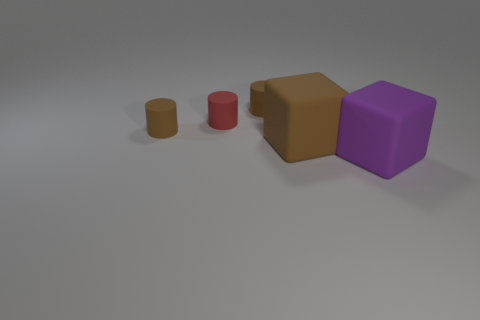Subtract all brown cylinders. How many cylinders are left? 1 Add 2 large yellow metallic objects. How many objects exist? 7 Subtract all brown cylinders. How many cylinders are left? 1 Subtract 2 cubes. How many cubes are left? 0 Subtract all purple spheres. Subtract all small red matte objects. How many objects are left? 4 Add 3 brown matte cylinders. How many brown matte cylinders are left? 5 Add 5 big purple matte cylinders. How many big purple matte cylinders exist? 5 Subtract 0 cyan cylinders. How many objects are left? 5 Subtract all cylinders. How many objects are left? 2 Subtract all yellow cylinders. Subtract all brown spheres. How many cylinders are left? 3 